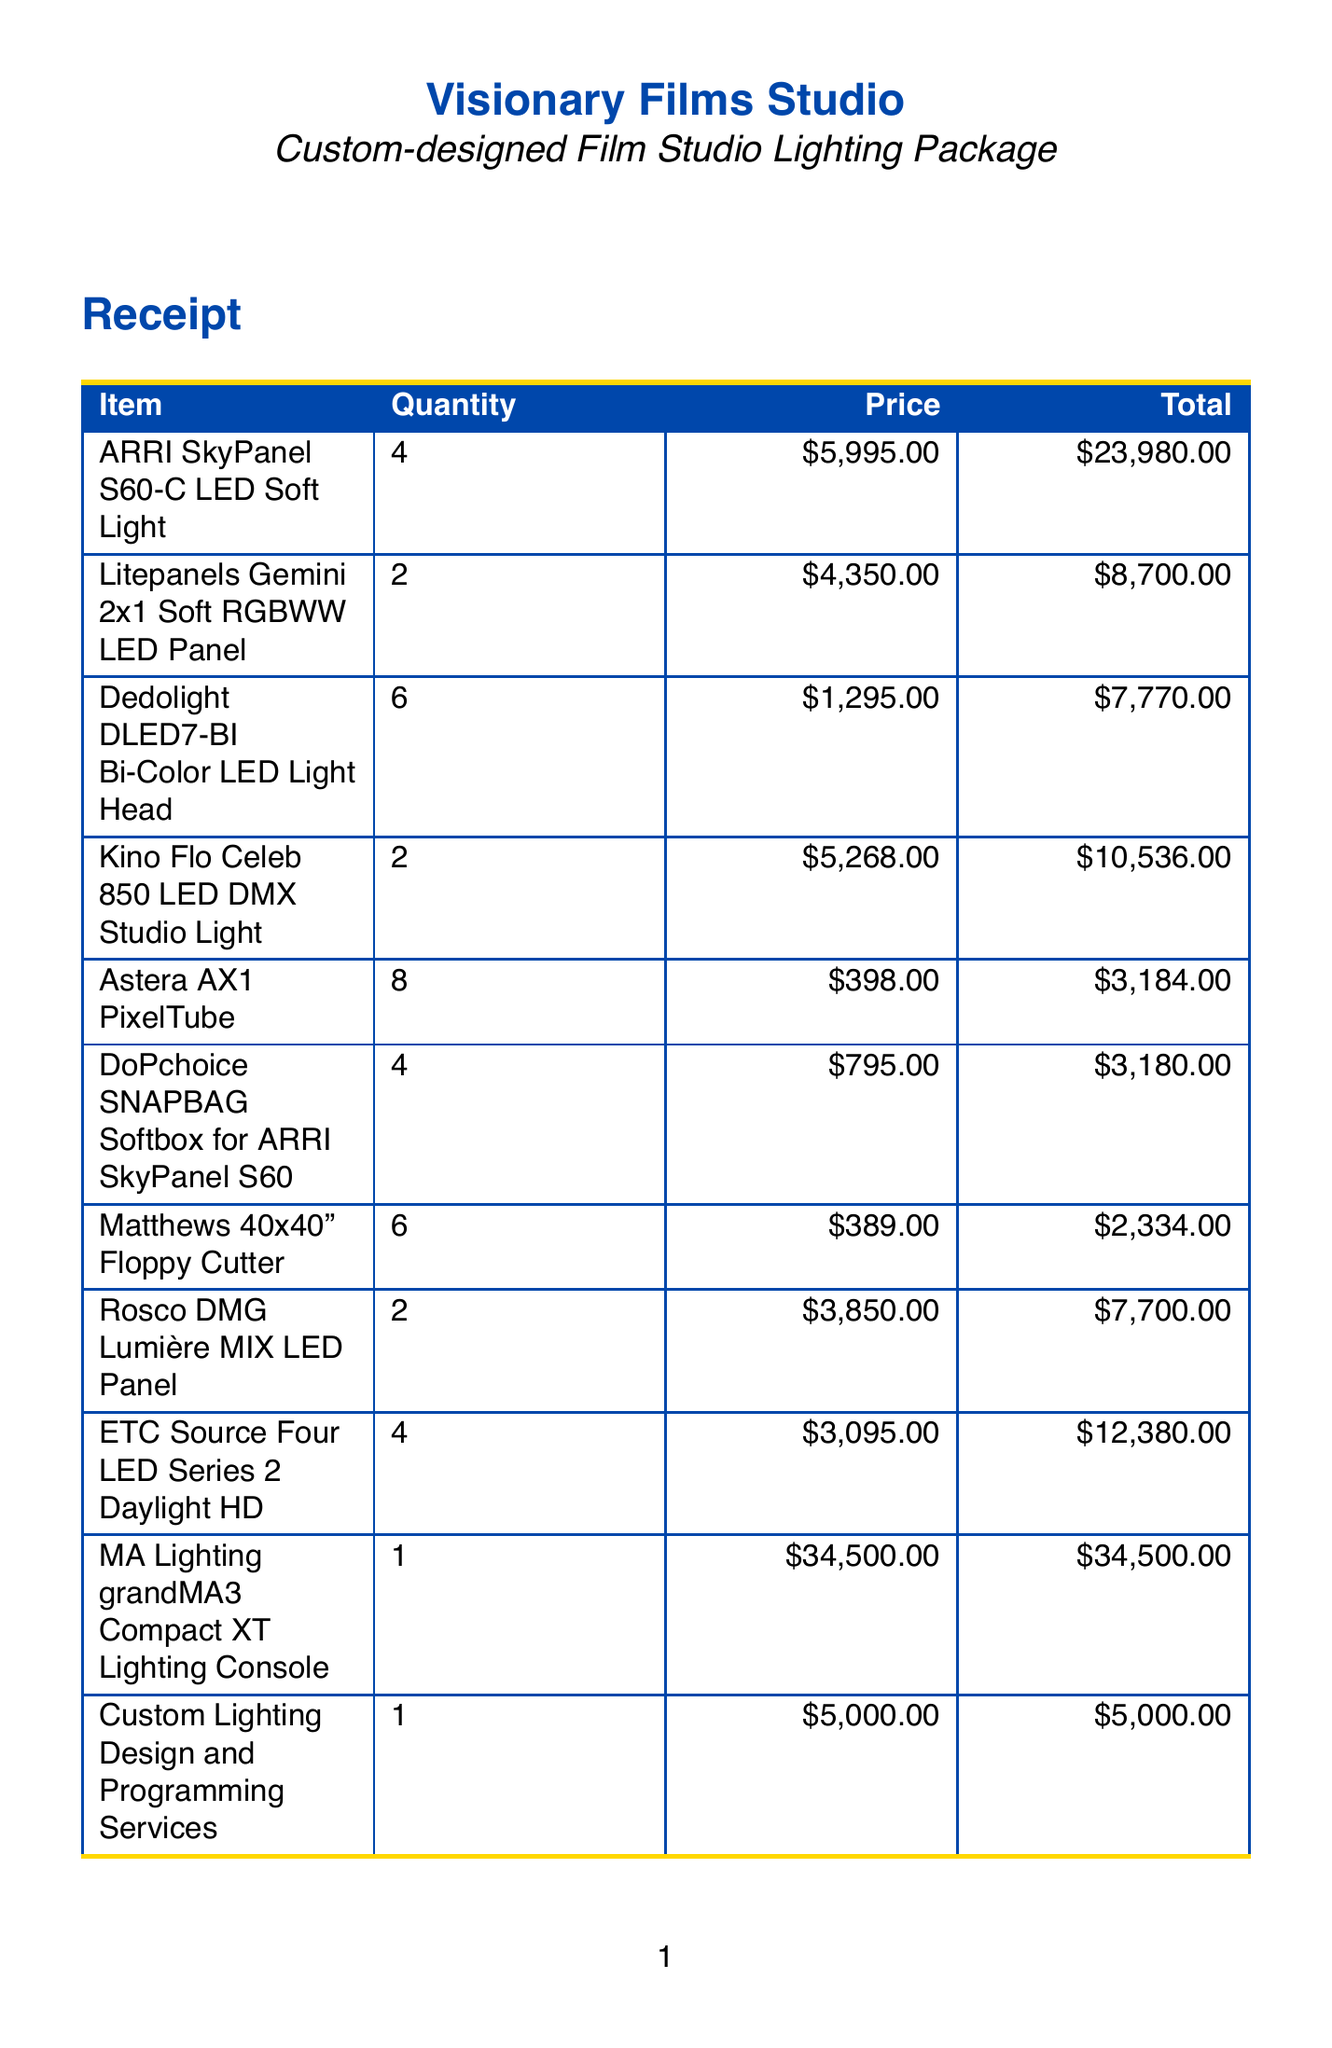What is the total amount due? The total amount due is listed at the bottom of the document as the final total calculation.
Answer: $119,264.00 How many ARRI SkyPanel S60-C LED Soft Lights are included? The document specifies the quantity of ARRI SkyPanel S60-C LED Soft Lights in the itemized list.
Answer: 4 What is the price of the MA Lighting grandMA3 Compact XT Lighting Console? The price for the MA Lighting grandMA3 Compact XT Lighting Console is listed alongside the item in the document.
Answer: $34,500.00 What type of support is available for equipment setup? The notes section mentions what type of support is available for the equipment setup.
Answer: On-site technician support What is the rental period for the equipment? The terms section of the document notes the rental period specified for equipment.
Answer: 4 weeks How many Litepanels Gemini 2x1 Soft RGBWW LED Panels are included? The quantity of Litepanels Gemini 2x1 Soft RGBWW LED Panels is indicated in the itemized list of the receipt.
Answer: 2 What are the payment terms regarding the deposit? The terms section outlines the payment terms, particularly focusing on the deposit requirements.
Answer: 50% deposit required What company is the recipient of this receipt? The recipient's name is prominently displayed at the top of the document.
Answer: Visionary Films Studio What service is offered for custom lighting design? The document includes a specific service that addresses the customer’s lighting design needs in the items list.
Answer: Custom Lighting Design and Programming Services 